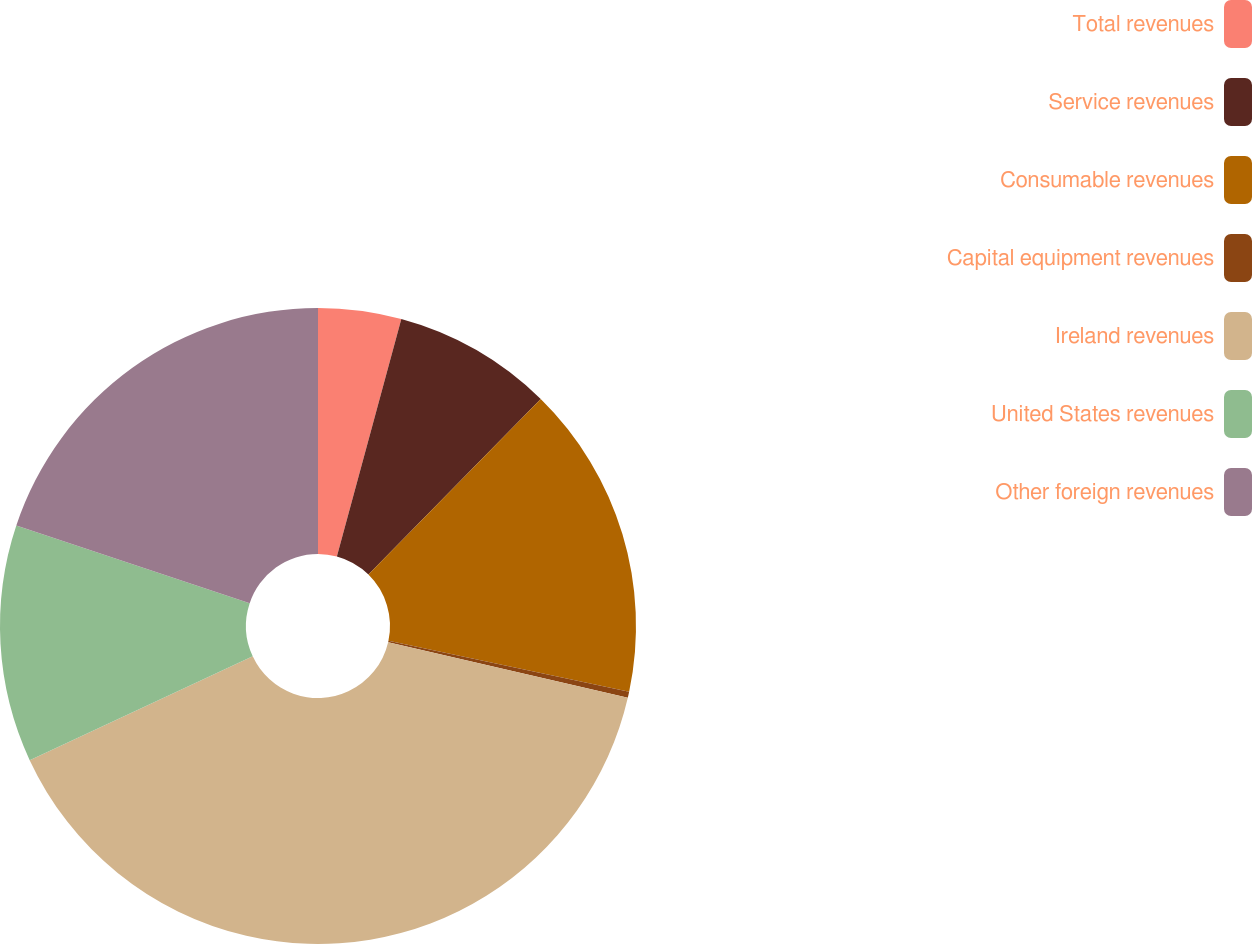Convert chart. <chart><loc_0><loc_0><loc_500><loc_500><pie_chart><fcel>Total revenues<fcel>Service revenues<fcel>Consumable revenues<fcel>Capital equipment revenues<fcel>Ireland revenues<fcel>United States revenues<fcel>Other foreign revenues<nl><fcel>4.22%<fcel>8.13%<fcel>15.96%<fcel>0.31%<fcel>39.45%<fcel>12.05%<fcel>19.88%<nl></chart> 